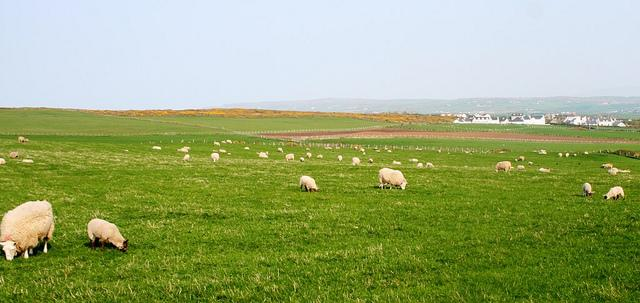What do these animals have? Please explain your reasoning. wool. White animals with fluffy white fur are grazing in an open pasture. sheep grow white wool. 